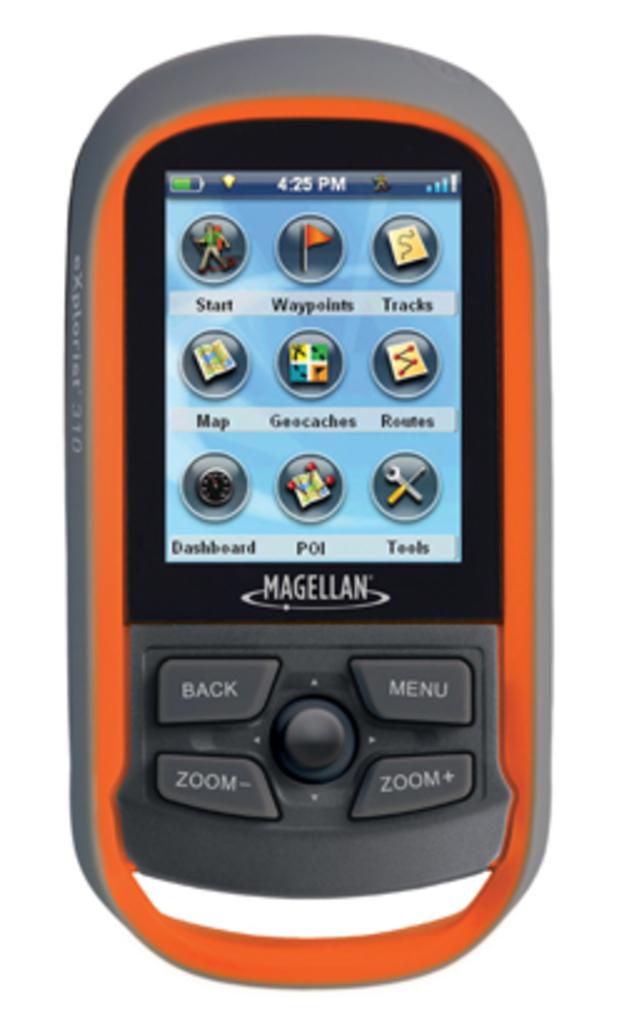<image>
Give a short and clear explanation of the subsequent image. An orange Magellan phone is at its menu. 